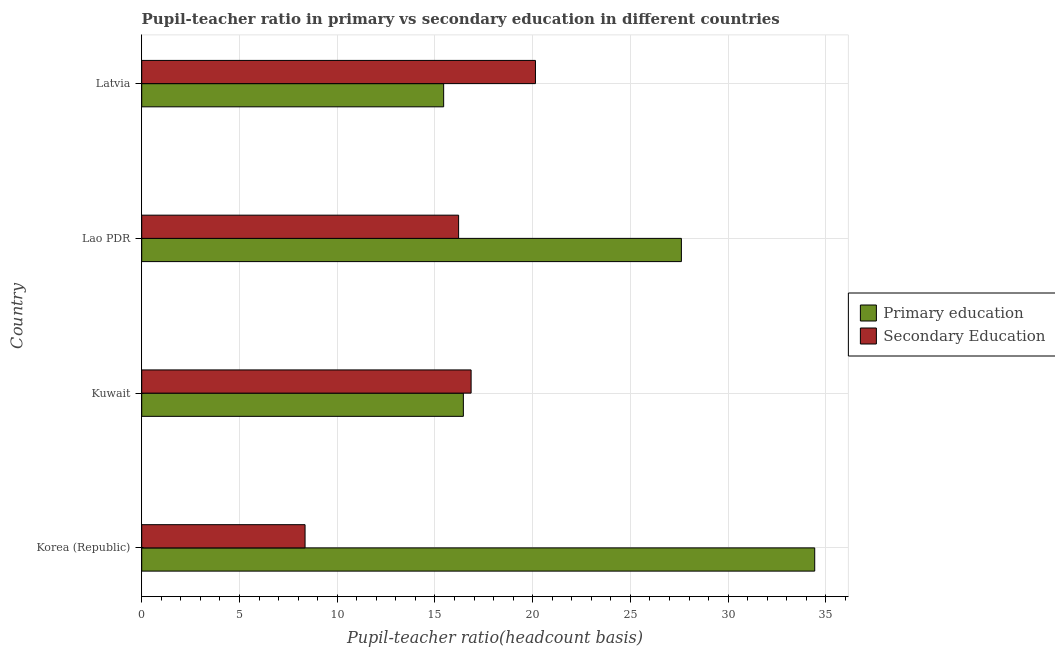How many different coloured bars are there?
Your response must be concise. 2. How many bars are there on the 3rd tick from the bottom?
Offer a terse response. 2. What is the label of the 2nd group of bars from the top?
Offer a very short reply. Lao PDR. In how many cases, is the number of bars for a given country not equal to the number of legend labels?
Keep it short and to the point. 0. What is the pupil-teacher ratio in primary education in Kuwait?
Keep it short and to the point. 16.45. Across all countries, what is the maximum pupil-teacher ratio in primary education?
Provide a succinct answer. 34.43. Across all countries, what is the minimum pupil-teacher ratio in primary education?
Provide a succinct answer. 15.45. In which country was the pupil-teacher ratio in primary education minimum?
Offer a terse response. Latvia. What is the total pupil teacher ratio on secondary education in the graph?
Provide a succinct answer. 61.56. What is the difference between the pupil teacher ratio on secondary education in Korea (Republic) and that in Latvia?
Offer a very short reply. -11.79. What is the difference between the pupil teacher ratio on secondary education in Latvia and the pupil-teacher ratio in primary education in Korea (Republic)?
Make the answer very short. -14.29. What is the average pupil teacher ratio on secondary education per country?
Provide a succinct answer. 15.39. What is the difference between the pupil-teacher ratio in primary education and pupil teacher ratio on secondary education in Latvia?
Your answer should be compact. -4.7. What is the ratio of the pupil teacher ratio on secondary education in Korea (Republic) to that in Lao PDR?
Ensure brevity in your answer.  0.52. Is the difference between the pupil teacher ratio on secondary education in Korea (Republic) and Latvia greater than the difference between the pupil-teacher ratio in primary education in Korea (Republic) and Latvia?
Ensure brevity in your answer.  No. What is the difference between the highest and the second highest pupil-teacher ratio in primary education?
Keep it short and to the point. 6.82. What is the difference between the highest and the lowest pupil-teacher ratio in primary education?
Make the answer very short. 18.98. In how many countries, is the pupil-teacher ratio in primary education greater than the average pupil-teacher ratio in primary education taken over all countries?
Offer a terse response. 2. What does the 1st bar from the bottom in Kuwait represents?
Offer a very short reply. Primary education. How many bars are there?
Provide a short and direct response. 8. Are all the bars in the graph horizontal?
Your answer should be very brief. Yes. Does the graph contain grids?
Offer a very short reply. Yes. Where does the legend appear in the graph?
Ensure brevity in your answer.  Center right. How many legend labels are there?
Your answer should be very brief. 2. How are the legend labels stacked?
Ensure brevity in your answer.  Vertical. What is the title of the graph?
Your response must be concise. Pupil-teacher ratio in primary vs secondary education in different countries. Does "Unregistered firms" appear as one of the legend labels in the graph?
Make the answer very short. No. What is the label or title of the X-axis?
Provide a short and direct response. Pupil-teacher ratio(headcount basis). What is the Pupil-teacher ratio(headcount basis) in Primary education in Korea (Republic)?
Make the answer very short. 34.43. What is the Pupil-teacher ratio(headcount basis) in Secondary Education in Korea (Republic)?
Your answer should be very brief. 8.36. What is the Pupil-teacher ratio(headcount basis) in Primary education in Kuwait?
Your answer should be very brief. 16.45. What is the Pupil-teacher ratio(headcount basis) of Secondary Education in Kuwait?
Make the answer very short. 16.85. What is the Pupil-teacher ratio(headcount basis) in Primary education in Lao PDR?
Your answer should be compact. 27.61. What is the Pupil-teacher ratio(headcount basis) in Secondary Education in Lao PDR?
Provide a succinct answer. 16.21. What is the Pupil-teacher ratio(headcount basis) in Primary education in Latvia?
Provide a short and direct response. 15.45. What is the Pupil-teacher ratio(headcount basis) of Secondary Education in Latvia?
Offer a very short reply. 20.14. Across all countries, what is the maximum Pupil-teacher ratio(headcount basis) of Primary education?
Provide a short and direct response. 34.43. Across all countries, what is the maximum Pupil-teacher ratio(headcount basis) of Secondary Education?
Offer a very short reply. 20.14. Across all countries, what is the minimum Pupil-teacher ratio(headcount basis) in Primary education?
Your answer should be very brief. 15.45. Across all countries, what is the minimum Pupil-teacher ratio(headcount basis) of Secondary Education?
Give a very brief answer. 8.36. What is the total Pupil-teacher ratio(headcount basis) of Primary education in the graph?
Your answer should be compact. 93.94. What is the total Pupil-teacher ratio(headcount basis) of Secondary Education in the graph?
Give a very brief answer. 61.56. What is the difference between the Pupil-teacher ratio(headcount basis) in Primary education in Korea (Republic) and that in Kuwait?
Your answer should be very brief. 17.98. What is the difference between the Pupil-teacher ratio(headcount basis) in Secondary Education in Korea (Republic) and that in Kuwait?
Offer a very short reply. -8.49. What is the difference between the Pupil-teacher ratio(headcount basis) of Primary education in Korea (Republic) and that in Lao PDR?
Provide a short and direct response. 6.82. What is the difference between the Pupil-teacher ratio(headcount basis) in Secondary Education in Korea (Republic) and that in Lao PDR?
Keep it short and to the point. -7.86. What is the difference between the Pupil-teacher ratio(headcount basis) of Primary education in Korea (Republic) and that in Latvia?
Provide a short and direct response. 18.98. What is the difference between the Pupil-teacher ratio(headcount basis) of Secondary Education in Korea (Republic) and that in Latvia?
Make the answer very short. -11.79. What is the difference between the Pupil-teacher ratio(headcount basis) of Primary education in Kuwait and that in Lao PDR?
Your answer should be very brief. -11.15. What is the difference between the Pupil-teacher ratio(headcount basis) in Secondary Education in Kuwait and that in Lao PDR?
Ensure brevity in your answer.  0.64. What is the difference between the Pupil-teacher ratio(headcount basis) in Secondary Education in Kuwait and that in Latvia?
Give a very brief answer. -3.29. What is the difference between the Pupil-teacher ratio(headcount basis) in Primary education in Lao PDR and that in Latvia?
Offer a very short reply. 12.16. What is the difference between the Pupil-teacher ratio(headcount basis) of Secondary Education in Lao PDR and that in Latvia?
Give a very brief answer. -3.93. What is the difference between the Pupil-teacher ratio(headcount basis) of Primary education in Korea (Republic) and the Pupil-teacher ratio(headcount basis) of Secondary Education in Kuwait?
Offer a terse response. 17.58. What is the difference between the Pupil-teacher ratio(headcount basis) of Primary education in Korea (Republic) and the Pupil-teacher ratio(headcount basis) of Secondary Education in Lao PDR?
Offer a very short reply. 18.22. What is the difference between the Pupil-teacher ratio(headcount basis) in Primary education in Korea (Republic) and the Pupil-teacher ratio(headcount basis) in Secondary Education in Latvia?
Provide a short and direct response. 14.29. What is the difference between the Pupil-teacher ratio(headcount basis) of Primary education in Kuwait and the Pupil-teacher ratio(headcount basis) of Secondary Education in Lao PDR?
Offer a very short reply. 0.24. What is the difference between the Pupil-teacher ratio(headcount basis) in Primary education in Kuwait and the Pupil-teacher ratio(headcount basis) in Secondary Education in Latvia?
Ensure brevity in your answer.  -3.69. What is the difference between the Pupil-teacher ratio(headcount basis) of Primary education in Lao PDR and the Pupil-teacher ratio(headcount basis) of Secondary Education in Latvia?
Give a very brief answer. 7.47. What is the average Pupil-teacher ratio(headcount basis) in Primary education per country?
Your response must be concise. 23.49. What is the average Pupil-teacher ratio(headcount basis) of Secondary Education per country?
Make the answer very short. 15.39. What is the difference between the Pupil-teacher ratio(headcount basis) of Primary education and Pupil-teacher ratio(headcount basis) of Secondary Education in Korea (Republic)?
Provide a short and direct response. 26.07. What is the difference between the Pupil-teacher ratio(headcount basis) in Primary education and Pupil-teacher ratio(headcount basis) in Secondary Education in Kuwait?
Make the answer very short. -0.4. What is the difference between the Pupil-teacher ratio(headcount basis) in Primary education and Pupil-teacher ratio(headcount basis) in Secondary Education in Lao PDR?
Keep it short and to the point. 11.4. What is the difference between the Pupil-teacher ratio(headcount basis) in Primary education and Pupil-teacher ratio(headcount basis) in Secondary Education in Latvia?
Your answer should be very brief. -4.7. What is the ratio of the Pupil-teacher ratio(headcount basis) of Primary education in Korea (Republic) to that in Kuwait?
Provide a succinct answer. 2.09. What is the ratio of the Pupil-teacher ratio(headcount basis) in Secondary Education in Korea (Republic) to that in Kuwait?
Offer a very short reply. 0.5. What is the ratio of the Pupil-teacher ratio(headcount basis) in Primary education in Korea (Republic) to that in Lao PDR?
Ensure brevity in your answer.  1.25. What is the ratio of the Pupil-teacher ratio(headcount basis) of Secondary Education in Korea (Republic) to that in Lao PDR?
Make the answer very short. 0.52. What is the ratio of the Pupil-teacher ratio(headcount basis) of Primary education in Korea (Republic) to that in Latvia?
Your answer should be very brief. 2.23. What is the ratio of the Pupil-teacher ratio(headcount basis) in Secondary Education in Korea (Republic) to that in Latvia?
Provide a short and direct response. 0.41. What is the ratio of the Pupil-teacher ratio(headcount basis) of Primary education in Kuwait to that in Lao PDR?
Your answer should be very brief. 0.6. What is the ratio of the Pupil-teacher ratio(headcount basis) of Secondary Education in Kuwait to that in Lao PDR?
Ensure brevity in your answer.  1.04. What is the ratio of the Pupil-teacher ratio(headcount basis) in Primary education in Kuwait to that in Latvia?
Your answer should be very brief. 1.07. What is the ratio of the Pupil-teacher ratio(headcount basis) of Secondary Education in Kuwait to that in Latvia?
Provide a short and direct response. 0.84. What is the ratio of the Pupil-teacher ratio(headcount basis) in Primary education in Lao PDR to that in Latvia?
Ensure brevity in your answer.  1.79. What is the ratio of the Pupil-teacher ratio(headcount basis) of Secondary Education in Lao PDR to that in Latvia?
Give a very brief answer. 0.8. What is the difference between the highest and the second highest Pupil-teacher ratio(headcount basis) of Primary education?
Your answer should be compact. 6.82. What is the difference between the highest and the second highest Pupil-teacher ratio(headcount basis) in Secondary Education?
Your response must be concise. 3.29. What is the difference between the highest and the lowest Pupil-teacher ratio(headcount basis) in Primary education?
Provide a short and direct response. 18.98. What is the difference between the highest and the lowest Pupil-teacher ratio(headcount basis) in Secondary Education?
Keep it short and to the point. 11.79. 